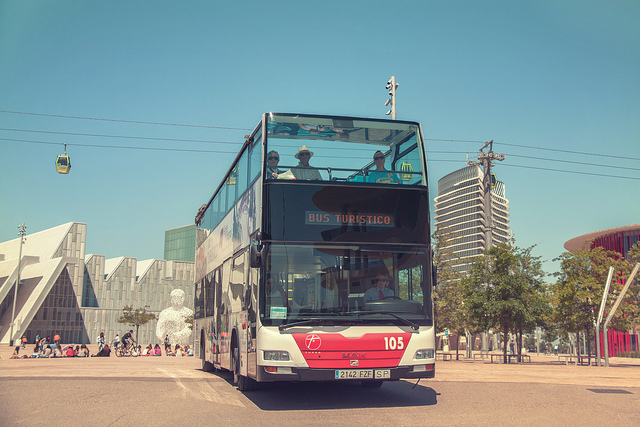Please transcribe the text in this image. BUS TURISTICO 105 2122 SP FZF 